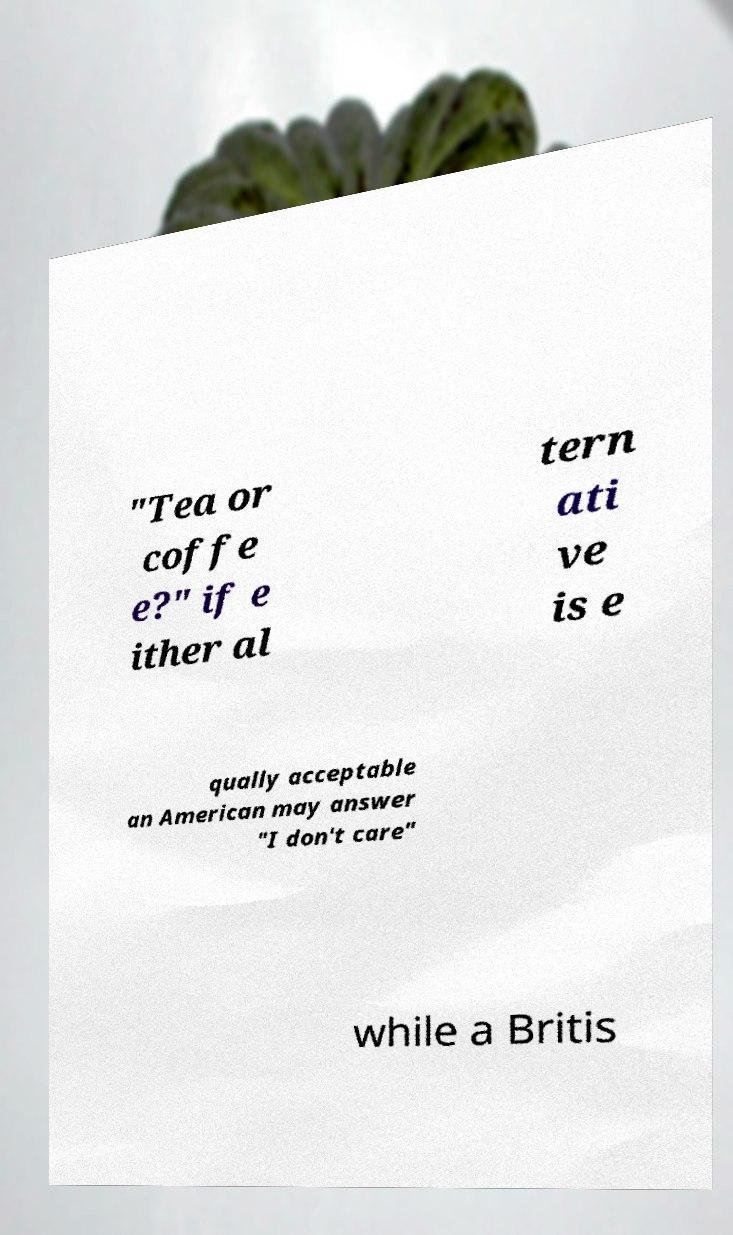Please identify and transcribe the text found in this image. "Tea or coffe e?" if e ither al tern ati ve is e qually acceptable an American may answer "I don't care" while a Britis 